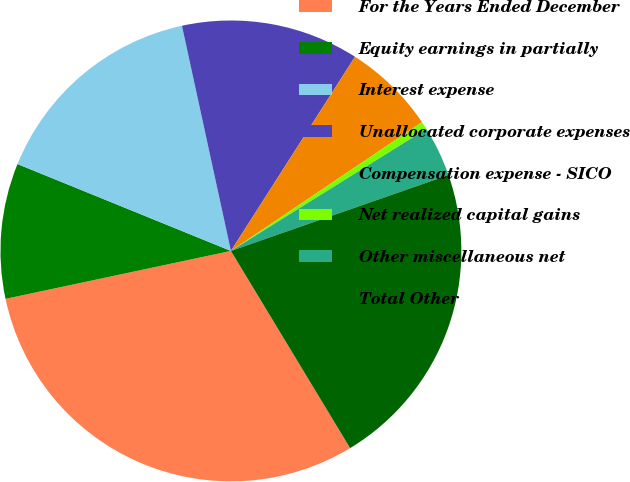<chart> <loc_0><loc_0><loc_500><loc_500><pie_chart><fcel>For the Years Ended December<fcel>Equity earnings in partially<fcel>Interest expense<fcel>Unallocated corporate expenses<fcel>Compensation expense - SICO<fcel>Net realized capital gains<fcel>Other miscellaneous net<fcel>Total Other<nl><fcel>30.32%<fcel>9.49%<fcel>15.44%<fcel>12.46%<fcel>6.51%<fcel>0.56%<fcel>3.54%<fcel>21.69%<nl></chart> 